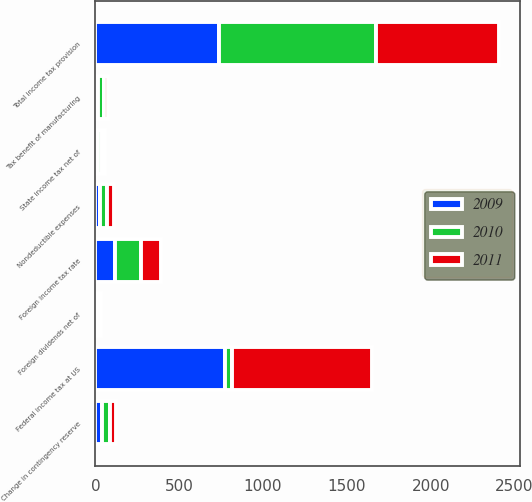Convert chart. <chart><loc_0><loc_0><loc_500><loc_500><stacked_bar_chart><ecel><fcel>Federal income tax at US<fcel>Foreign income tax rate<fcel>State income tax net of<fcel>Nondeductible expenses<fcel>Tax benefit of manufacturing<fcel>Foreign dividends net of<fcel>Change in contingency reserve<fcel>Total income tax provision<nl><fcel>2010<fcel>40<fcel>152<fcel>22<fcel>42<fcel>37<fcel>9<fcel>48<fcel>937<nl><fcel>2011<fcel>839<fcel>117<fcel>17<fcel>40<fcel>19<fcel>15<fcel>37<fcel>738<nl><fcel>2009<fcel>773<fcel>120<fcel>18<fcel>30<fcel>17<fcel>10<fcel>41<fcel>735<nl></chart> 